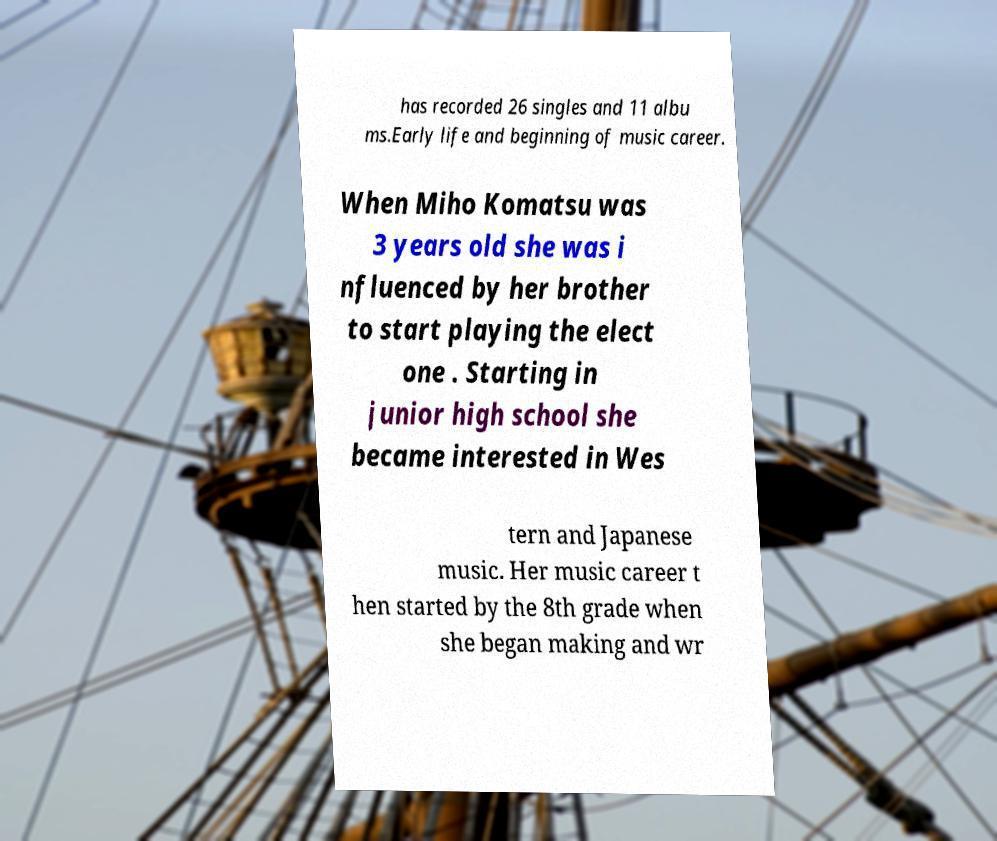Could you extract and type out the text from this image? has recorded 26 singles and 11 albu ms.Early life and beginning of music career. When Miho Komatsu was 3 years old she was i nfluenced by her brother to start playing the elect one . Starting in junior high school she became interested in Wes tern and Japanese music. Her music career t hen started by the 8th grade when she began making and wr 